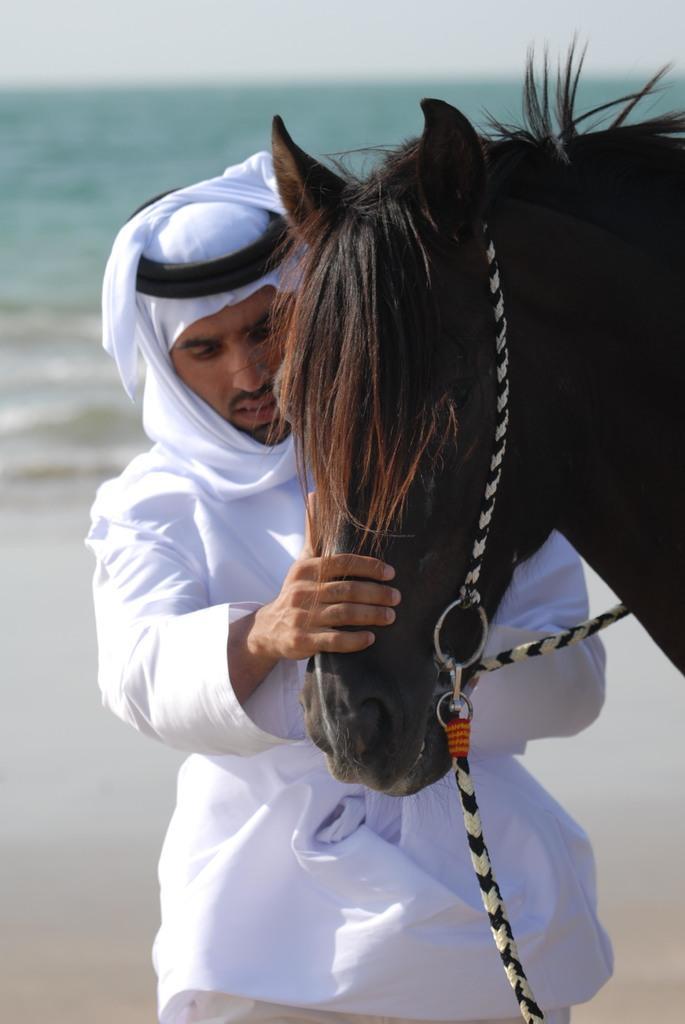Please provide a concise description of this image. This place seems to be a beach. On the right side there is a horse. Behind a man is wearing white color dress, standing and holding the head of this horse. In the background, I can see the water. At the top of the image I can see the sky. 